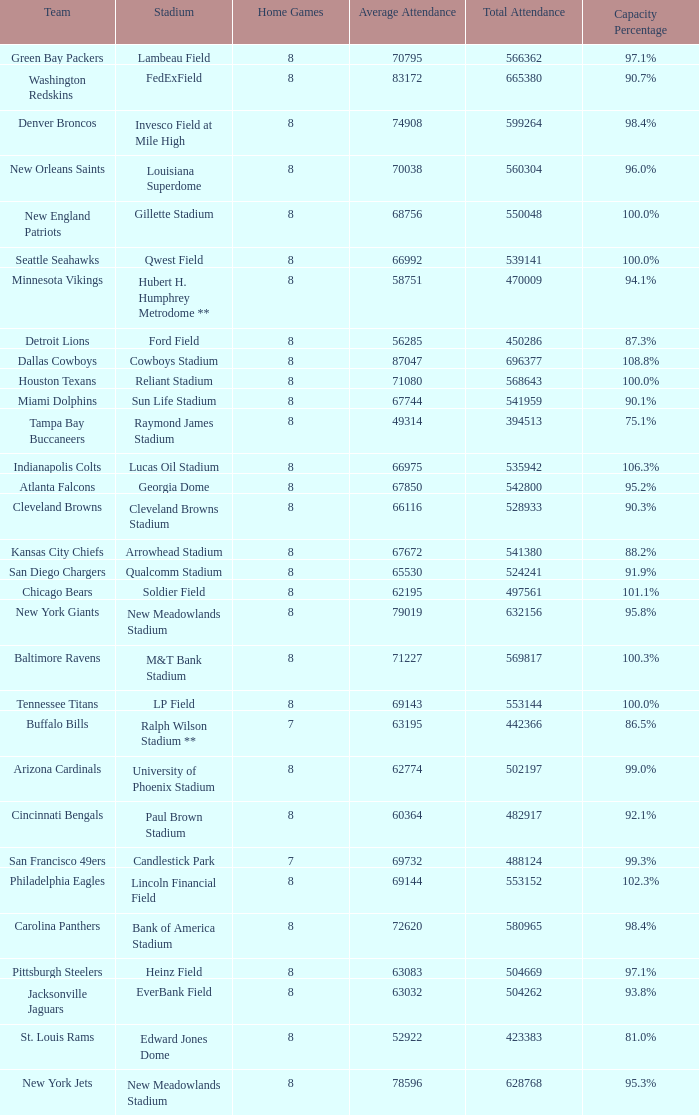What was the capacity for the Denver Broncos? 98.4%. 